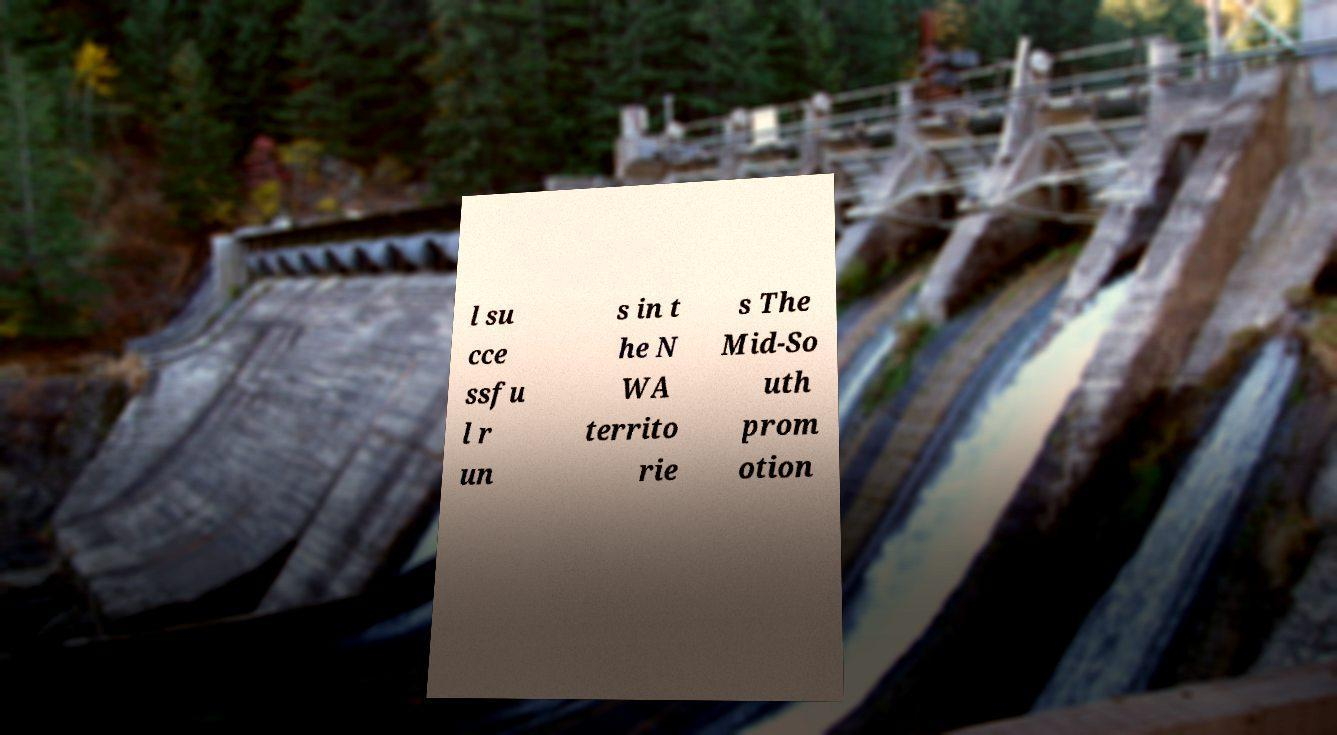Could you assist in decoding the text presented in this image and type it out clearly? l su cce ssfu l r un s in t he N WA territo rie s The Mid-So uth prom otion 